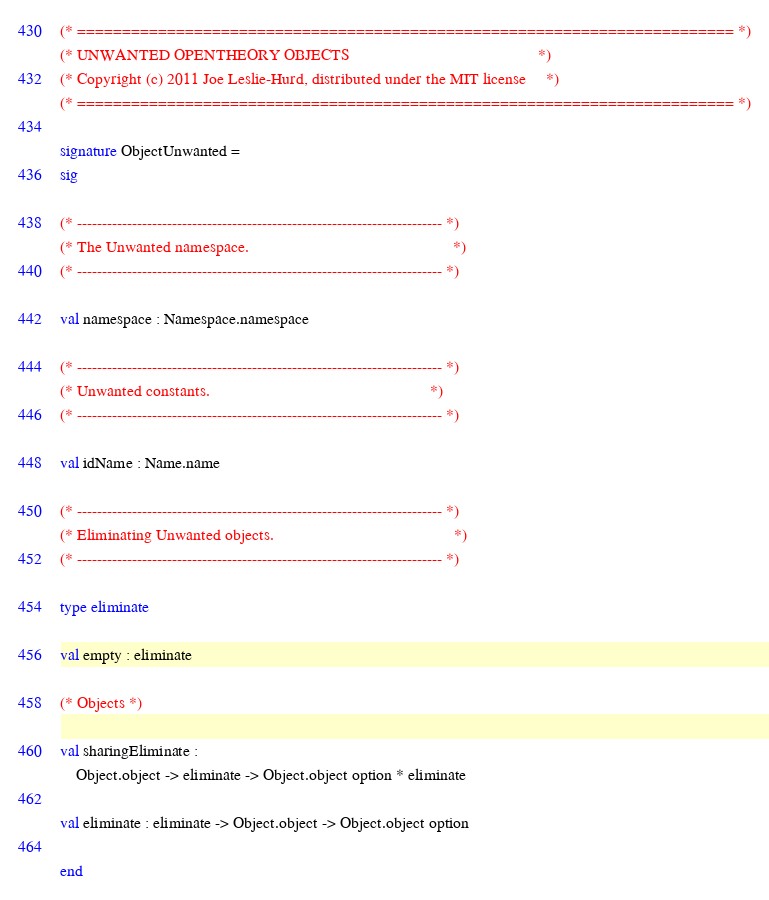<code> <loc_0><loc_0><loc_500><loc_500><_SML_>(* ========================================================================= *)
(* UNWANTED OPENTHEORY OBJECTS                                               *)
(* Copyright (c) 2011 Joe Leslie-Hurd, distributed under the MIT license     *)
(* ========================================================================= *)

signature ObjectUnwanted =
sig

(* ------------------------------------------------------------------------- *)
(* The Unwanted namespace.                                                   *)
(* ------------------------------------------------------------------------- *)

val namespace : Namespace.namespace

(* ------------------------------------------------------------------------- *)
(* Unwanted constants.                                                       *)
(* ------------------------------------------------------------------------- *)

val idName : Name.name

(* ------------------------------------------------------------------------- *)
(* Eliminating Unwanted objects.                                             *)
(* ------------------------------------------------------------------------- *)

type eliminate

val empty : eliminate

(* Objects *)

val sharingEliminate :
    Object.object -> eliminate -> Object.object option * eliminate

val eliminate : eliminate -> Object.object -> Object.object option

end
</code> 